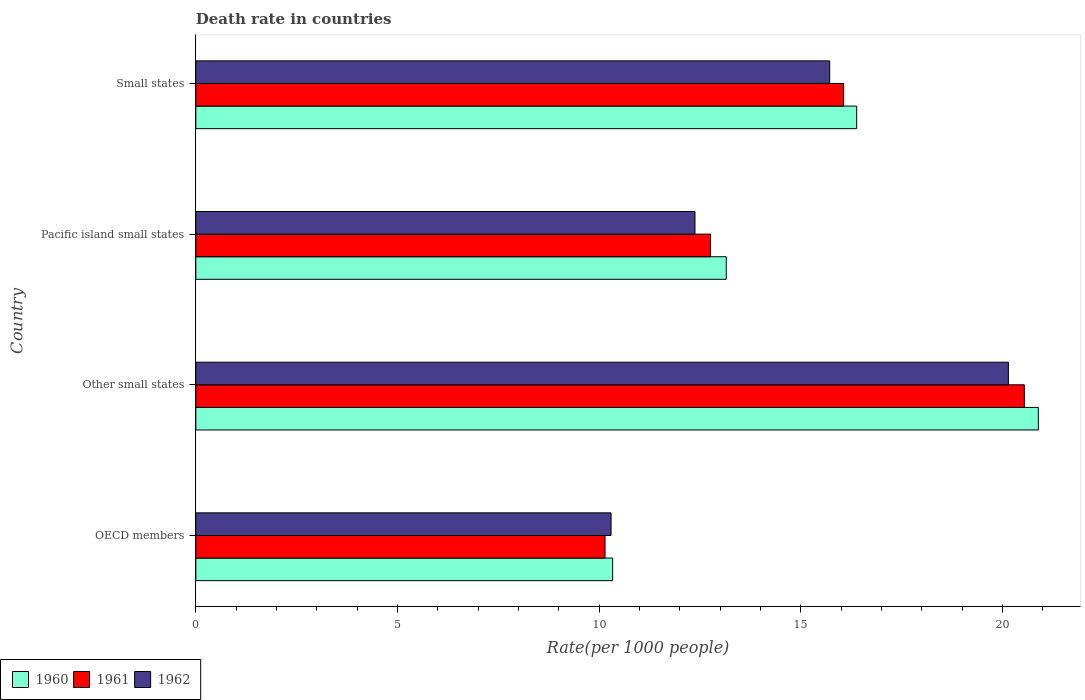How many groups of bars are there?
Provide a short and direct response. 4. Are the number of bars per tick equal to the number of legend labels?
Provide a succinct answer. Yes. Are the number of bars on each tick of the Y-axis equal?
Offer a very short reply. Yes. How many bars are there on the 3rd tick from the bottom?
Your answer should be compact. 3. What is the label of the 3rd group of bars from the top?
Your response must be concise. Other small states. In how many cases, is the number of bars for a given country not equal to the number of legend labels?
Offer a very short reply. 0. What is the death rate in 1962 in Small states?
Your response must be concise. 15.72. Across all countries, what is the maximum death rate in 1961?
Make the answer very short. 20.54. Across all countries, what is the minimum death rate in 1962?
Offer a very short reply. 10.3. In which country was the death rate in 1961 maximum?
Provide a short and direct response. Other small states. What is the total death rate in 1961 in the graph?
Keep it short and to the point. 59.51. What is the difference between the death rate in 1962 in OECD members and that in Small states?
Provide a succinct answer. -5.42. What is the difference between the death rate in 1960 in Other small states and the death rate in 1962 in Small states?
Give a very brief answer. 5.17. What is the average death rate in 1962 per country?
Offer a very short reply. 14.63. What is the difference between the death rate in 1962 and death rate in 1961 in Other small states?
Give a very brief answer. -0.4. What is the ratio of the death rate in 1962 in Pacific island small states to that in Small states?
Ensure brevity in your answer.  0.79. Is the death rate in 1960 in OECD members less than that in Small states?
Offer a terse response. Yes. Is the difference between the death rate in 1962 in OECD members and Pacific island small states greater than the difference between the death rate in 1961 in OECD members and Pacific island small states?
Your answer should be compact. Yes. What is the difference between the highest and the second highest death rate in 1960?
Provide a short and direct response. 4.5. What is the difference between the highest and the lowest death rate in 1962?
Make the answer very short. 9.85. What does the 1st bar from the bottom in Small states represents?
Offer a very short reply. 1960. Is it the case that in every country, the sum of the death rate in 1961 and death rate in 1962 is greater than the death rate in 1960?
Give a very brief answer. Yes. How many bars are there?
Give a very brief answer. 12. How many countries are there in the graph?
Provide a succinct answer. 4. What is the difference between two consecutive major ticks on the X-axis?
Your response must be concise. 5. Are the values on the major ticks of X-axis written in scientific E-notation?
Keep it short and to the point. No. Does the graph contain grids?
Keep it short and to the point. No. How are the legend labels stacked?
Offer a very short reply. Horizontal. What is the title of the graph?
Your answer should be compact. Death rate in countries. Does "2002" appear as one of the legend labels in the graph?
Give a very brief answer. No. What is the label or title of the X-axis?
Offer a terse response. Rate(per 1000 people). What is the label or title of the Y-axis?
Ensure brevity in your answer.  Country. What is the Rate(per 1000 people) in 1960 in OECD members?
Your response must be concise. 10.33. What is the Rate(per 1000 people) of 1961 in OECD members?
Your answer should be very brief. 10.15. What is the Rate(per 1000 people) of 1962 in OECD members?
Your response must be concise. 10.3. What is the Rate(per 1000 people) in 1960 in Other small states?
Offer a very short reply. 20.89. What is the Rate(per 1000 people) in 1961 in Other small states?
Offer a very short reply. 20.54. What is the Rate(per 1000 people) of 1962 in Other small states?
Your response must be concise. 20.15. What is the Rate(per 1000 people) in 1960 in Pacific island small states?
Provide a succinct answer. 13.15. What is the Rate(per 1000 people) in 1961 in Pacific island small states?
Give a very brief answer. 12.76. What is the Rate(per 1000 people) in 1962 in Pacific island small states?
Your answer should be very brief. 12.38. What is the Rate(per 1000 people) of 1960 in Small states?
Give a very brief answer. 16.38. What is the Rate(per 1000 people) in 1961 in Small states?
Offer a very short reply. 16.06. What is the Rate(per 1000 people) of 1962 in Small states?
Offer a very short reply. 15.72. Across all countries, what is the maximum Rate(per 1000 people) in 1960?
Keep it short and to the point. 20.89. Across all countries, what is the maximum Rate(per 1000 people) in 1961?
Your answer should be compact. 20.54. Across all countries, what is the maximum Rate(per 1000 people) in 1962?
Ensure brevity in your answer.  20.15. Across all countries, what is the minimum Rate(per 1000 people) of 1960?
Offer a very short reply. 10.33. Across all countries, what is the minimum Rate(per 1000 people) of 1961?
Offer a very short reply. 10.15. Across all countries, what is the minimum Rate(per 1000 people) in 1962?
Your response must be concise. 10.3. What is the total Rate(per 1000 people) in 1960 in the graph?
Your response must be concise. 60.76. What is the total Rate(per 1000 people) of 1961 in the graph?
Your response must be concise. 59.51. What is the total Rate(per 1000 people) in 1962 in the graph?
Offer a terse response. 58.53. What is the difference between the Rate(per 1000 people) in 1960 in OECD members and that in Other small states?
Your answer should be very brief. -10.56. What is the difference between the Rate(per 1000 people) of 1961 in OECD members and that in Other small states?
Your answer should be very brief. -10.4. What is the difference between the Rate(per 1000 people) of 1962 in OECD members and that in Other small states?
Provide a short and direct response. -9.85. What is the difference between the Rate(per 1000 people) in 1960 in OECD members and that in Pacific island small states?
Your response must be concise. -2.82. What is the difference between the Rate(per 1000 people) of 1961 in OECD members and that in Pacific island small states?
Keep it short and to the point. -2.62. What is the difference between the Rate(per 1000 people) of 1962 in OECD members and that in Pacific island small states?
Your answer should be compact. -2.08. What is the difference between the Rate(per 1000 people) of 1960 in OECD members and that in Small states?
Your response must be concise. -6.05. What is the difference between the Rate(per 1000 people) in 1961 in OECD members and that in Small states?
Keep it short and to the point. -5.92. What is the difference between the Rate(per 1000 people) in 1962 in OECD members and that in Small states?
Provide a succinct answer. -5.42. What is the difference between the Rate(per 1000 people) in 1960 in Other small states and that in Pacific island small states?
Provide a succinct answer. 7.74. What is the difference between the Rate(per 1000 people) of 1961 in Other small states and that in Pacific island small states?
Offer a terse response. 7.78. What is the difference between the Rate(per 1000 people) of 1962 in Other small states and that in Pacific island small states?
Ensure brevity in your answer.  7.77. What is the difference between the Rate(per 1000 people) of 1960 in Other small states and that in Small states?
Make the answer very short. 4.5. What is the difference between the Rate(per 1000 people) of 1961 in Other small states and that in Small states?
Make the answer very short. 4.48. What is the difference between the Rate(per 1000 people) in 1962 in Other small states and that in Small states?
Provide a succinct answer. 4.43. What is the difference between the Rate(per 1000 people) in 1960 in Pacific island small states and that in Small states?
Ensure brevity in your answer.  -3.23. What is the difference between the Rate(per 1000 people) in 1961 in Pacific island small states and that in Small states?
Ensure brevity in your answer.  -3.3. What is the difference between the Rate(per 1000 people) of 1962 in Pacific island small states and that in Small states?
Give a very brief answer. -3.34. What is the difference between the Rate(per 1000 people) of 1960 in OECD members and the Rate(per 1000 people) of 1961 in Other small states?
Keep it short and to the point. -10.21. What is the difference between the Rate(per 1000 people) in 1960 in OECD members and the Rate(per 1000 people) in 1962 in Other small states?
Keep it short and to the point. -9.81. What is the difference between the Rate(per 1000 people) of 1961 in OECD members and the Rate(per 1000 people) of 1962 in Other small states?
Your answer should be very brief. -10. What is the difference between the Rate(per 1000 people) in 1960 in OECD members and the Rate(per 1000 people) in 1961 in Pacific island small states?
Offer a very short reply. -2.43. What is the difference between the Rate(per 1000 people) of 1960 in OECD members and the Rate(per 1000 people) of 1962 in Pacific island small states?
Provide a short and direct response. -2.04. What is the difference between the Rate(per 1000 people) of 1961 in OECD members and the Rate(per 1000 people) of 1962 in Pacific island small states?
Give a very brief answer. -2.23. What is the difference between the Rate(per 1000 people) in 1960 in OECD members and the Rate(per 1000 people) in 1961 in Small states?
Offer a very short reply. -5.73. What is the difference between the Rate(per 1000 people) in 1960 in OECD members and the Rate(per 1000 people) in 1962 in Small states?
Offer a very short reply. -5.38. What is the difference between the Rate(per 1000 people) of 1961 in OECD members and the Rate(per 1000 people) of 1962 in Small states?
Provide a short and direct response. -5.57. What is the difference between the Rate(per 1000 people) in 1960 in Other small states and the Rate(per 1000 people) in 1961 in Pacific island small states?
Ensure brevity in your answer.  8.13. What is the difference between the Rate(per 1000 people) of 1960 in Other small states and the Rate(per 1000 people) of 1962 in Pacific island small states?
Give a very brief answer. 8.51. What is the difference between the Rate(per 1000 people) in 1961 in Other small states and the Rate(per 1000 people) in 1962 in Pacific island small states?
Offer a very short reply. 8.17. What is the difference between the Rate(per 1000 people) of 1960 in Other small states and the Rate(per 1000 people) of 1961 in Small states?
Offer a terse response. 4.83. What is the difference between the Rate(per 1000 people) in 1960 in Other small states and the Rate(per 1000 people) in 1962 in Small states?
Your response must be concise. 5.17. What is the difference between the Rate(per 1000 people) in 1961 in Other small states and the Rate(per 1000 people) in 1962 in Small states?
Offer a very short reply. 4.83. What is the difference between the Rate(per 1000 people) in 1960 in Pacific island small states and the Rate(per 1000 people) in 1961 in Small states?
Provide a succinct answer. -2.91. What is the difference between the Rate(per 1000 people) in 1960 in Pacific island small states and the Rate(per 1000 people) in 1962 in Small states?
Offer a very short reply. -2.57. What is the difference between the Rate(per 1000 people) of 1961 in Pacific island small states and the Rate(per 1000 people) of 1962 in Small states?
Ensure brevity in your answer.  -2.95. What is the average Rate(per 1000 people) in 1960 per country?
Provide a short and direct response. 15.19. What is the average Rate(per 1000 people) of 1961 per country?
Provide a short and direct response. 14.88. What is the average Rate(per 1000 people) in 1962 per country?
Offer a very short reply. 14.63. What is the difference between the Rate(per 1000 people) of 1960 and Rate(per 1000 people) of 1961 in OECD members?
Provide a short and direct response. 0.19. What is the difference between the Rate(per 1000 people) in 1960 and Rate(per 1000 people) in 1962 in OECD members?
Offer a terse response. 0.04. What is the difference between the Rate(per 1000 people) in 1961 and Rate(per 1000 people) in 1962 in OECD members?
Provide a short and direct response. -0.15. What is the difference between the Rate(per 1000 people) in 1960 and Rate(per 1000 people) in 1961 in Other small states?
Your answer should be very brief. 0.35. What is the difference between the Rate(per 1000 people) of 1960 and Rate(per 1000 people) of 1962 in Other small states?
Provide a short and direct response. 0.74. What is the difference between the Rate(per 1000 people) of 1961 and Rate(per 1000 people) of 1962 in Other small states?
Your answer should be very brief. 0.4. What is the difference between the Rate(per 1000 people) of 1960 and Rate(per 1000 people) of 1961 in Pacific island small states?
Make the answer very short. 0.39. What is the difference between the Rate(per 1000 people) of 1960 and Rate(per 1000 people) of 1962 in Pacific island small states?
Keep it short and to the point. 0.77. What is the difference between the Rate(per 1000 people) of 1961 and Rate(per 1000 people) of 1962 in Pacific island small states?
Your answer should be very brief. 0.39. What is the difference between the Rate(per 1000 people) in 1960 and Rate(per 1000 people) in 1961 in Small states?
Make the answer very short. 0.32. What is the difference between the Rate(per 1000 people) in 1960 and Rate(per 1000 people) in 1962 in Small states?
Provide a short and direct response. 0.67. What is the difference between the Rate(per 1000 people) of 1961 and Rate(per 1000 people) of 1962 in Small states?
Offer a terse response. 0.35. What is the ratio of the Rate(per 1000 people) of 1960 in OECD members to that in Other small states?
Provide a short and direct response. 0.49. What is the ratio of the Rate(per 1000 people) in 1961 in OECD members to that in Other small states?
Your response must be concise. 0.49. What is the ratio of the Rate(per 1000 people) of 1962 in OECD members to that in Other small states?
Offer a terse response. 0.51. What is the ratio of the Rate(per 1000 people) in 1960 in OECD members to that in Pacific island small states?
Provide a short and direct response. 0.79. What is the ratio of the Rate(per 1000 people) of 1961 in OECD members to that in Pacific island small states?
Offer a terse response. 0.8. What is the ratio of the Rate(per 1000 people) of 1962 in OECD members to that in Pacific island small states?
Provide a short and direct response. 0.83. What is the ratio of the Rate(per 1000 people) in 1960 in OECD members to that in Small states?
Make the answer very short. 0.63. What is the ratio of the Rate(per 1000 people) of 1961 in OECD members to that in Small states?
Your response must be concise. 0.63. What is the ratio of the Rate(per 1000 people) of 1962 in OECD members to that in Small states?
Offer a very short reply. 0.66. What is the ratio of the Rate(per 1000 people) in 1960 in Other small states to that in Pacific island small states?
Your response must be concise. 1.59. What is the ratio of the Rate(per 1000 people) in 1961 in Other small states to that in Pacific island small states?
Your answer should be very brief. 1.61. What is the ratio of the Rate(per 1000 people) of 1962 in Other small states to that in Pacific island small states?
Offer a very short reply. 1.63. What is the ratio of the Rate(per 1000 people) in 1960 in Other small states to that in Small states?
Keep it short and to the point. 1.27. What is the ratio of the Rate(per 1000 people) of 1961 in Other small states to that in Small states?
Offer a terse response. 1.28. What is the ratio of the Rate(per 1000 people) of 1962 in Other small states to that in Small states?
Provide a short and direct response. 1.28. What is the ratio of the Rate(per 1000 people) of 1960 in Pacific island small states to that in Small states?
Offer a very short reply. 0.8. What is the ratio of the Rate(per 1000 people) in 1961 in Pacific island small states to that in Small states?
Make the answer very short. 0.79. What is the ratio of the Rate(per 1000 people) in 1962 in Pacific island small states to that in Small states?
Ensure brevity in your answer.  0.79. What is the difference between the highest and the second highest Rate(per 1000 people) of 1960?
Your answer should be compact. 4.5. What is the difference between the highest and the second highest Rate(per 1000 people) in 1961?
Provide a succinct answer. 4.48. What is the difference between the highest and the second highest Rate(per 1000 people) in 1962?
Keep it short and to the point. 4.43. What is the difference between the highest and the lowest Rate(per 1000 people) in 1960?
Your answer should be compact. 10.56. What is the difference between the highest and the lowest Rate(per 1000 people) of 1961?
Give a very brief answer. 10.4. What is the difference between the highest and the lowest Rate(per 1000 people) in 1962?
Give a very brief answer. 9.85. 